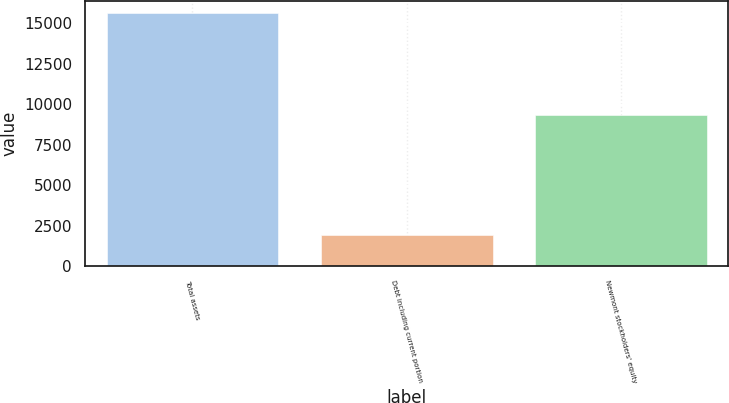<chart> <loc_0><loc_0><loc_500><loc_500><bar_chart><fcel>Total assets<fcel>Debt including current portion<fcel>Newmont stockholders' equity<nl><fcel>15601<fcel>1911<fcel>9337<nl></chart> 